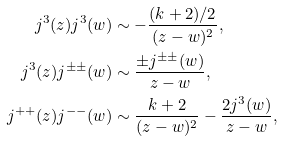<formula> <loc_0><loc_0><loc_500><loc_500>j ^ { 3 } ( z ) j ^ { 3 } ( w ) & \sim - \frac { ( k + 2 ) / 2 } { ( z - w ) ^ { 2 } } , \\ j ^ { 3 } ( z ) j ^ { \pm \pm } ( w ) & \sim \frac { \pm j ^ { \pm \pm } ( w ) } { z - w } , \\ j ^ { + + } ( z ) j ^ { - - } ( w ) & \sim \frac { k + 2 } { ( z - w ) ^ { 2 } } - \frac { 2 j ^ { 3 } ( w ) } { z - w } ,</formula> 